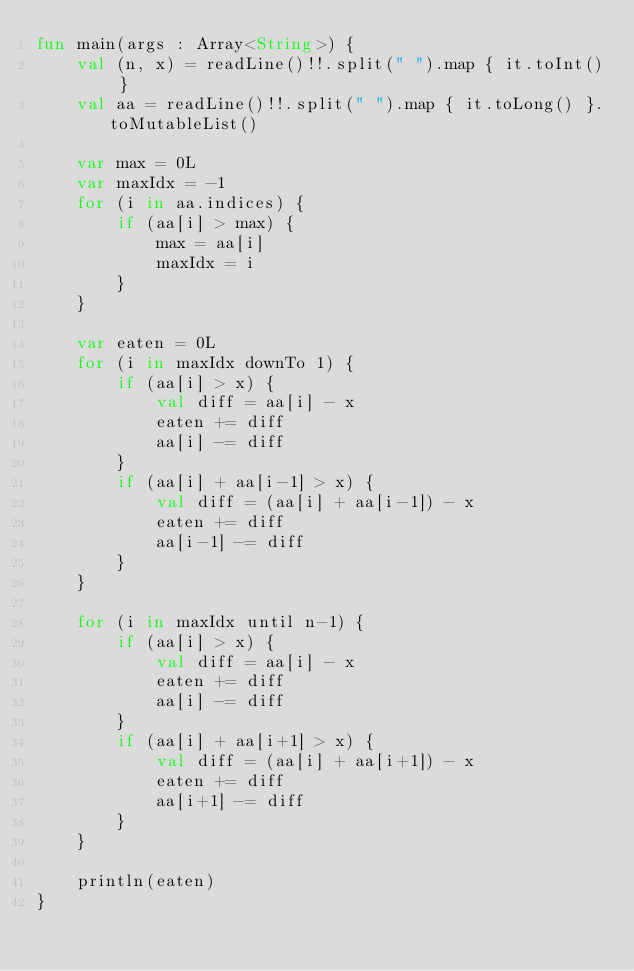Convert code to text. <code><loc_0><loc_0><loc_500><loc_500><_Kotlin_>fun main(args : Array<String>) {
    val (n, x) = readLine()!!.split(" ").map { it.toInt() }
    val aa = readLine()!!.split(" ").map { it.toLong() }.toMutableList()

    var max = 0L
    var maxIdx = -1
    for (i in aa.indices) {
        if (aa[i] > max) {
            max = aa[i]
            maxIdx = i
        }
    }

    var eaten = 0L
    for (i in maxIdx downTo 1) {
        if (aa[i] > x) {
            val diff = aa[i] - x
            eaten += diff
            aa[i] -= diff
        }
        if (aa[i] + aa[i-1] > x) {
            val diff = (aa[i] + aa[i-1]) - x
            eaten += diff
            aa[i-1] -= diff
        }
    }

    for (i in maxIdx until n-1) {
        if (aa[i] > x) {
            val diff = aa[i] - x
            eaten += diff
            aa[i] -= diff
        }
        if (aa[i] + aa[i+1] > x) {
            val diff = (aa[i] + aa[i+1]) - x
            eaten += diff
            aa[i+1] -= diff
        }
    }

    println(eaten)
}</code> 